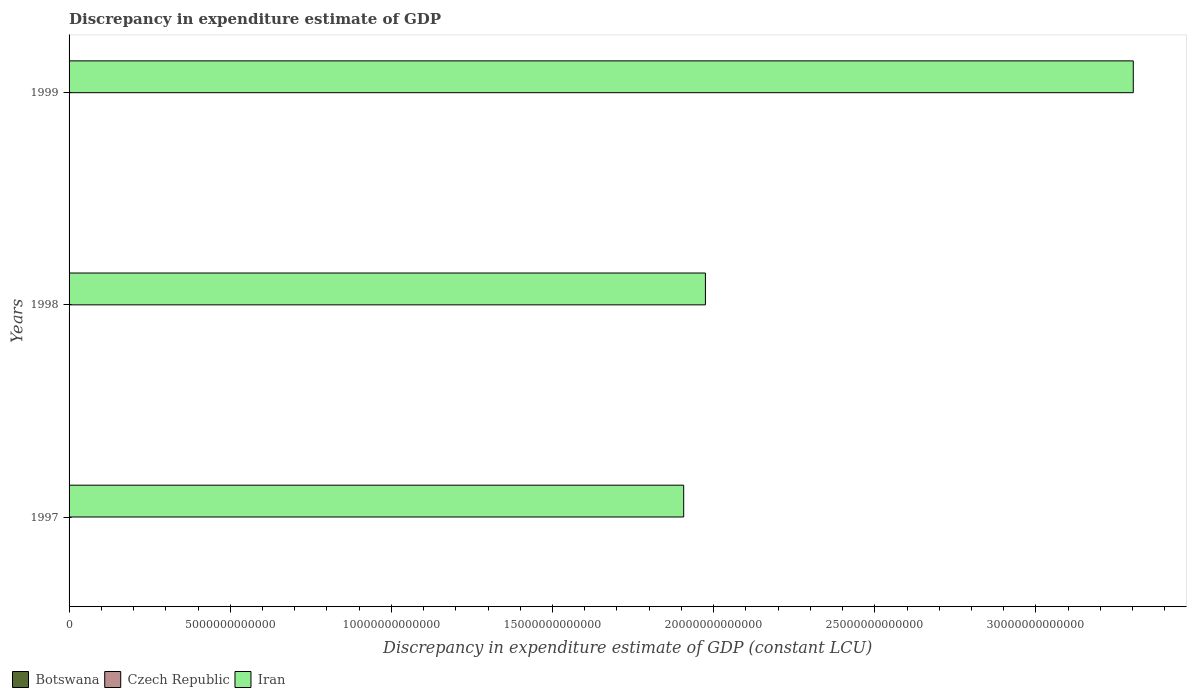How many groups of bars are there?
Ensure brevity in your answer.  3. How many bars are there on the 1st tick from the bottom?
Your answer should be compact. 2. What is the label of the 2nd group of bars from the top?
Your response must be concise. 1998. What is the discrepancy in expenditure estimate of GDP in Czech Republic in 1998?
Your answer should be very brief. 0. Across all years, what is the maximum discrepancy in expenditure estimate of GDP in Botswana?
Your answer should be compact. 2.86e+09. Across all years, what is the minimum discrepancy in expenditure estimate of GDP in Iran?
Ensure brevity in your answer.  1.91e+13. What is the total discrepancy in expenditure estimate of GDP in Botswana in the graph?
Keep it short and to the point. 6.06e+09. What is the difference between the discrepancy in expenditure estimate of GDP in Iran in 1997 and that in 1999?
Give a very brief answer. -1.39e+13. What is the difference between the discrepancy in expenditure estimate of GDP in Iran in 1997 and the discrepancy in expenditure estimate of GDP in Botswana in 1999?
Offer a very short reply. 1.91e+13. What is the average discrepancy in expenditure estimate of GDP in Botswana per year?
Your response must be concise. 2.02e+09. In the year 1997, what is the difference between the discrepancy in expenditure estimate of GDP in Botswana and discrepancy in expenditure estimate of GDP in Iran?
Make the answer very short. -1.91e+13. In how many years, is the discrepancy in expenditure estimate of GDP in Czech Republic greater than 13000000000000 LCU?
Ensure brevity in your answer.  0. What is the ratio of the discrepancy in expenditure estimate of GDP in Botswana in 1997 to that in 1999?
Your answer should be compact. 0.43. What is the difference between the highest and the second highest discrepancy in expenditure estimate of GDP in Iran?
Your answer should be compact. 1.33e+13. What is the difference between the highest and the lowest discrepancy in expenditure estimate of GDP in Iran?
Your response must be concise. 1.39e+13. In how many years, is the discrepancy in expenditure estimate of GDP in Iran greater than the average discrepancy in expenditure estimate of GDP in Iran taken over all years?
Your answer should be compact. 1. Is the sum of the discrepancy in expenditure estimate of GDP in Botswana in 1998 and 1999 greater than the maximum discrepancy in expenditure estimate of GDP in Czech Republic across all years?
Ensure brevity in your answer.  Yes. Is it the case that in every year, the sum of the discrepancy in expenditure estimate of GDP in Iran and discrepancy in expenditure estimate of GDP in Czech Republic is greater than the discrepancy in expenditure estimate of GDP in Botswana?
Provide a short and direct response. Yes. How many bars are there?
Your answer should be very brief. 6. What is the difference between two consecutive major ticks on the X-axis?
Your answer should be very brief. 5.00e+12. Does the graph contain any zero values?
Offer a very short reply. Yes. Does the graph contain grids?
Give a very brief answer. No. Where does the legend appear in the graph?
Offer a very short reply. Bottom left. How are the legend labels stacked?
Your answer should be compact. Horizontal. What is the title of the graph?
Provide a succinct answer. Discrepancy in expenditure estimate of GDP. What is the label or title of the X-axis?
Provide a succinct answer. Discrepancy in expenditure estimate of GDP (constant LCU). What is the label or title of the Y-axis?
Ensure brevity in your answer.  Years. What is the Discrepancy in expenditure estimate of GDP (constant LCU) of Botswana in 1997?
Offer a terse response. 1.24e+09. What is the Discrepancy in expenditure estimate of GDP (constant LCU) of Czech Republic in 1997?
Provide a short and direct response. 0. What is the Discrepancy in expenditure estimate of GDP (constant LCU) of Iran in 1997?
Keep it short and to the point. 1.91e+13. What is the Discrepancy in expenditure estimate of GDP (constant LCU) of Botswana in 1998?
Offer a very short reply. 1.96e+09. What is the Discrepancy in expenditure estimate of GDP (constant LCU) in Iran in 1998?
Ensure brevity in your answer.  1.97e+13. What is the Discrepancy in expenditure estimate of GDP (constant LCU) of Botswana in 1999?
Keep it short and to the point. 2.86e+09. What is the Discrepancy in expenditure estimate of GDP (constant LCU) of Czech Republic in 1999?
Ensure brevity in your answer.  0. What is the Discrepancy in expenditure estimate of GDP (constant LCU) in Iran in 1999?
Offer a very short reply. 3.30e+13. Across all years, what is the maximum Discrepancy in expenditure estimate of GDP (constant LCU) in Botswana?
Keep it short and to the point. 2.86e+09. Across all years, what is the maximum Discrepancy in expenditure estimate of GDP (constant LCU) in Iran?
Provide a succinct answer. 3.30e+13. Across all years, what is the minimum Discrepancy in expenditure estimate of GDP (constant LCU) of Botswana?
Your response must be concise. 1.24e+09. Across all years, what is the minimum Discrepancy in expenditure estimate of GDP (constant LCU) in Iran?
Offer a very short reply. 1.91e+13. What is the total Discrepancy in expenditure estimate of GDP (constant LCU) in Botswana in the graph?
Provide a succinct answer. 6.06e+09. What is the total Discrepancy in expenditure estimate of GDP (constant LCU) in Iran in the graph?
Your answer should be very brief. 7.18e+13. What is the difference between the Discrepancy in expenditure estimate of GDP (constant LCU) in Botswana in 1997 and that in 1998?
Your response must be concise. -7.21e+08. What is the difference between the Discrepancy in expenditure estimate of GDP (constant LCU) of Iran in 1997 and that in 1998?
Provide a short and direct response. -6.74e+11. What is the difference between the Discrepancy in expenditure estimate of GDP (constant LCU) in Botswana in 1997 and that in 1999?
Offer a very short reply. -1.62e+09. What is the difference between the Discrepancy in expenditure estimate of GDP (constant LCU) of Iran in 1997 and that in 1999?
Keep it short and to the point. -1.39e+13. What is the difference between the Discrepancy in expenditure estimate of GDP (constant LCU) of Botswana in 1998 and that in 1999?
Provide a succinct answer. -9.03e+08. What is the difference between the Discrepancy in expenditure estimate of GDP (constant LCU) in Iran in 1998 and that in 1999?
Offer a terse response. -1.33e+13. What is the difference between the Discrepancy in expenditure estimate of GDP (constant LCU) of Botswana in 1997 and the Discrepancy in expenditure estimate of GDP (constant LCU) of Iran in 1998?
Provide a succinct answer. -1.97e+13. What is the difference between the Discrepancy in expenditure estimate of GDP (constant LCU) of Botswana in 1997 and the Discrepancy in expenditure estimate of GDP (constant LCU) of Iran in 1999?
Give a very brief answer. -3.30e+13. What is the difference between the Discrepancy in expenditure estimate of GDP (constant LCU) in Botswana in 1998 and the Discrepancy in expenditure estimate of GDP (constant LCU) in Iran in 1999?
Give a very brief answer. -3.30e+13. What is the average Discrepancy in expenditure estimate of GDP (constant LCU) of Botswana per year?
Ensure brevity in your answer.  2.02e+09. What is the average Discrepancy in expenditure estimate of GDP (constant LCU) in Czech Republic per year?
Offer a terse response. 0. What is the average Discrepancy in expenditure estimate of GDP (constant LCU) in Iran per year?
Give a very brief answer. 2.39e+13. In the year 1997, what is the difference between the Discrepancy in expenditure estimate of GDP (constant LCU) of Botswana and Discrepancy in expenditure estimate of GDP (constant LCU) of Iran?
Ensure brevity in your answer.  -1.91e+13. In the year 1998, what is the difference between the Discrepancy in expenditure estimate of GDP (constant LCU) in Botswana and Discrepancy in expenditure estimate of GDP (constant LCU) in Iran?
Offer a terse response. -1.97e+13. In the year 1999, what is the difference between the Discrepancy in expenditure estimate of GDP (constant LCU) of Botswana and Discrepancy in expenditure estimate of GDP (constant LCU) of Iran?
Keep it short and to the point. -3.30e+13. What is the ratio of the Discrepancy in expenditure estimate of GDP (constant LCU) of Botswana in 1997 to that in 1998?
Provide a succinct answer. 0.63. What is the ratio of the Discrepancy in expenditure estimate of GDP (constant LCU) of Iran in 1997 to that in 1998?
Keep it short and to the point. 0.97. What is the ratio of the Discrepancy in expenditure estimate of GDP (constant LCU) of Botswana in 1997 to that in 1999?
Your response must be concise. 0.43. What is the ratio of the Discrepancy in expenditure estimate of GDP (constant LCU) of Iran in 1997 to that in 1999?
Your answer should be compact. 0.58. What is the ratio of the Discrepancy in expenditure estimate of GDP (constant LCU) in Botswana in 1998 to that in 1999?
Your answer should be very brief. 0.68. What is the ratio of the Discrepancy in expenditure estimate of GDP (constant LCU) in Iran in 1998 to that in 1999?
Provide a succinct answer. 0.6. What is the difference between the highest and the second highest Discrepancy in expenditure estimate of GDP (constant LCU) of Botswana?
Give a very brief answer. 9.03e+08. What is the difference between the highest and the second highest Discrepancy in expenditure estimate of GDP (constant LCU) of Iran?
Your response must be concise. 1.33e+13. What is the difference between the highest and the lowest Discrepancy in expenditure estimate of GDP (constant LCU) of Botswana?
Offer a very short reply. 1.62e+09. What is the difference between the highest and the lowest Discrepancy in expenditure estimate of GDP (constant LCU) of Iran?
Provide a short and direct response. 1.39e+13. 